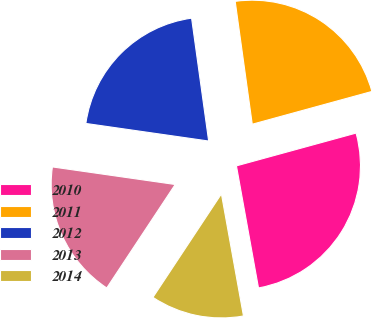<chart> <loc_0><loc_0><loc_500><loc_500><pie_chart><fcel>2010<fcel>2011<fcel>2012<fcel>2013<fcel>2014<nl><fcel>26.41%<fcel>22.94%<fcel>20.54%<fcel>17.96%<fcel>12.15%<nl></chart> 